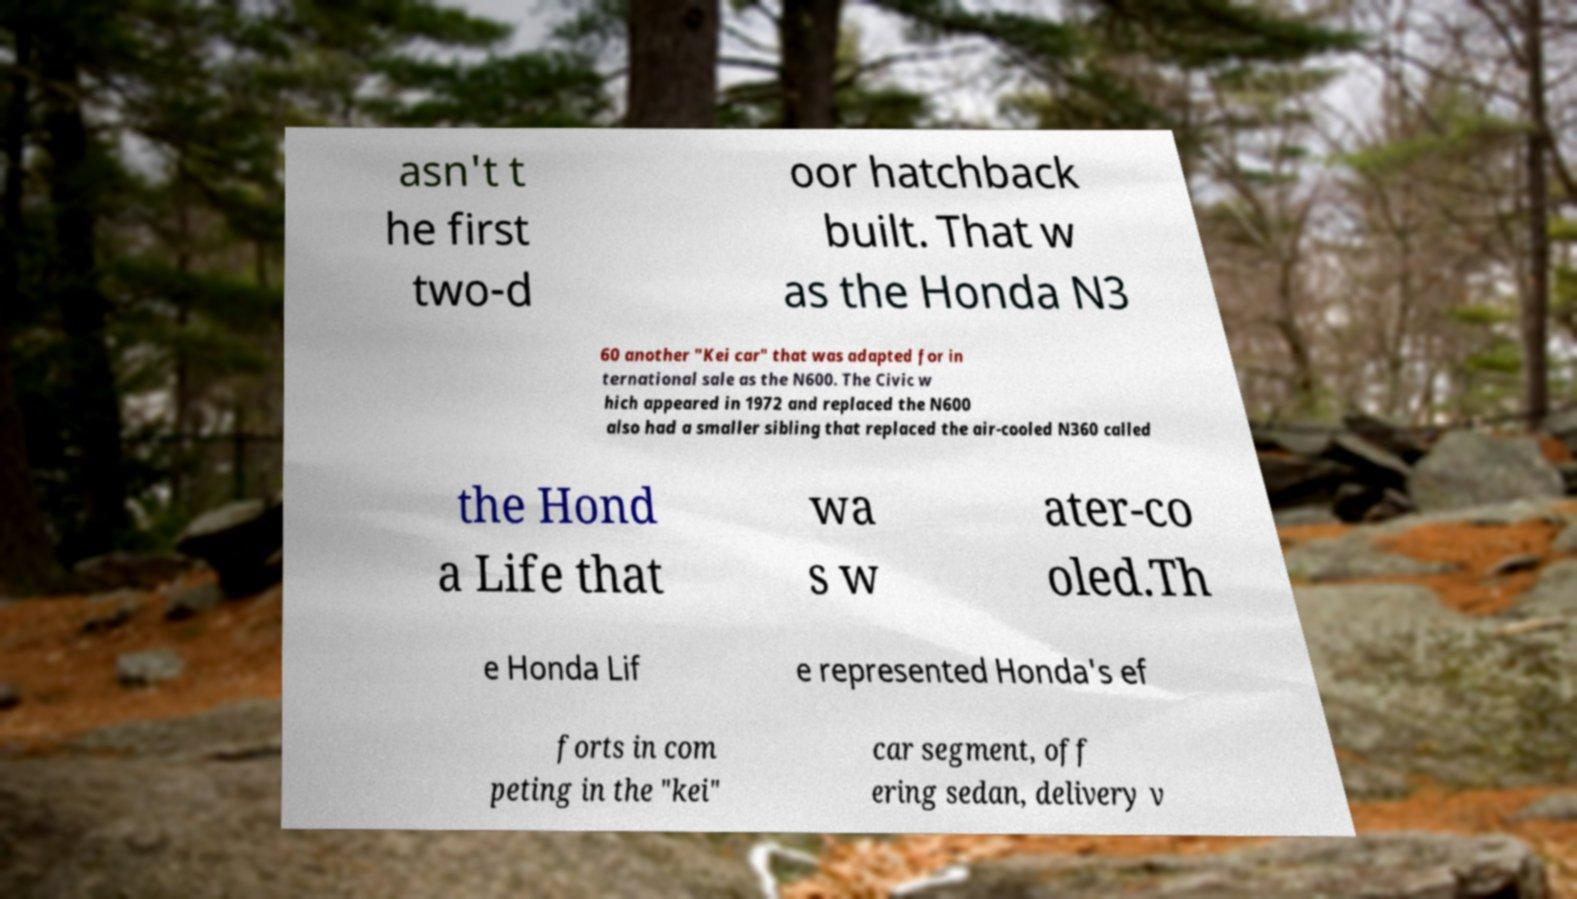Could you assist in decoding the text presented in this image and type it out clearly? asn't t he first two-d oor hatchback built. That w as the Honda N3 60 another "Kei car" that was adapted for in ternational sale as the N600. The Civic w hich appeared in 1972 and replaced the N600 also had a smaller sibling that replaced the air-cooled N360 called the Hond a Life that wa s w ater-co oled.Th e Honda Lif e represented Honda's ef forts in com peting in the "kei" car segment, off ering sedan, delivery v 